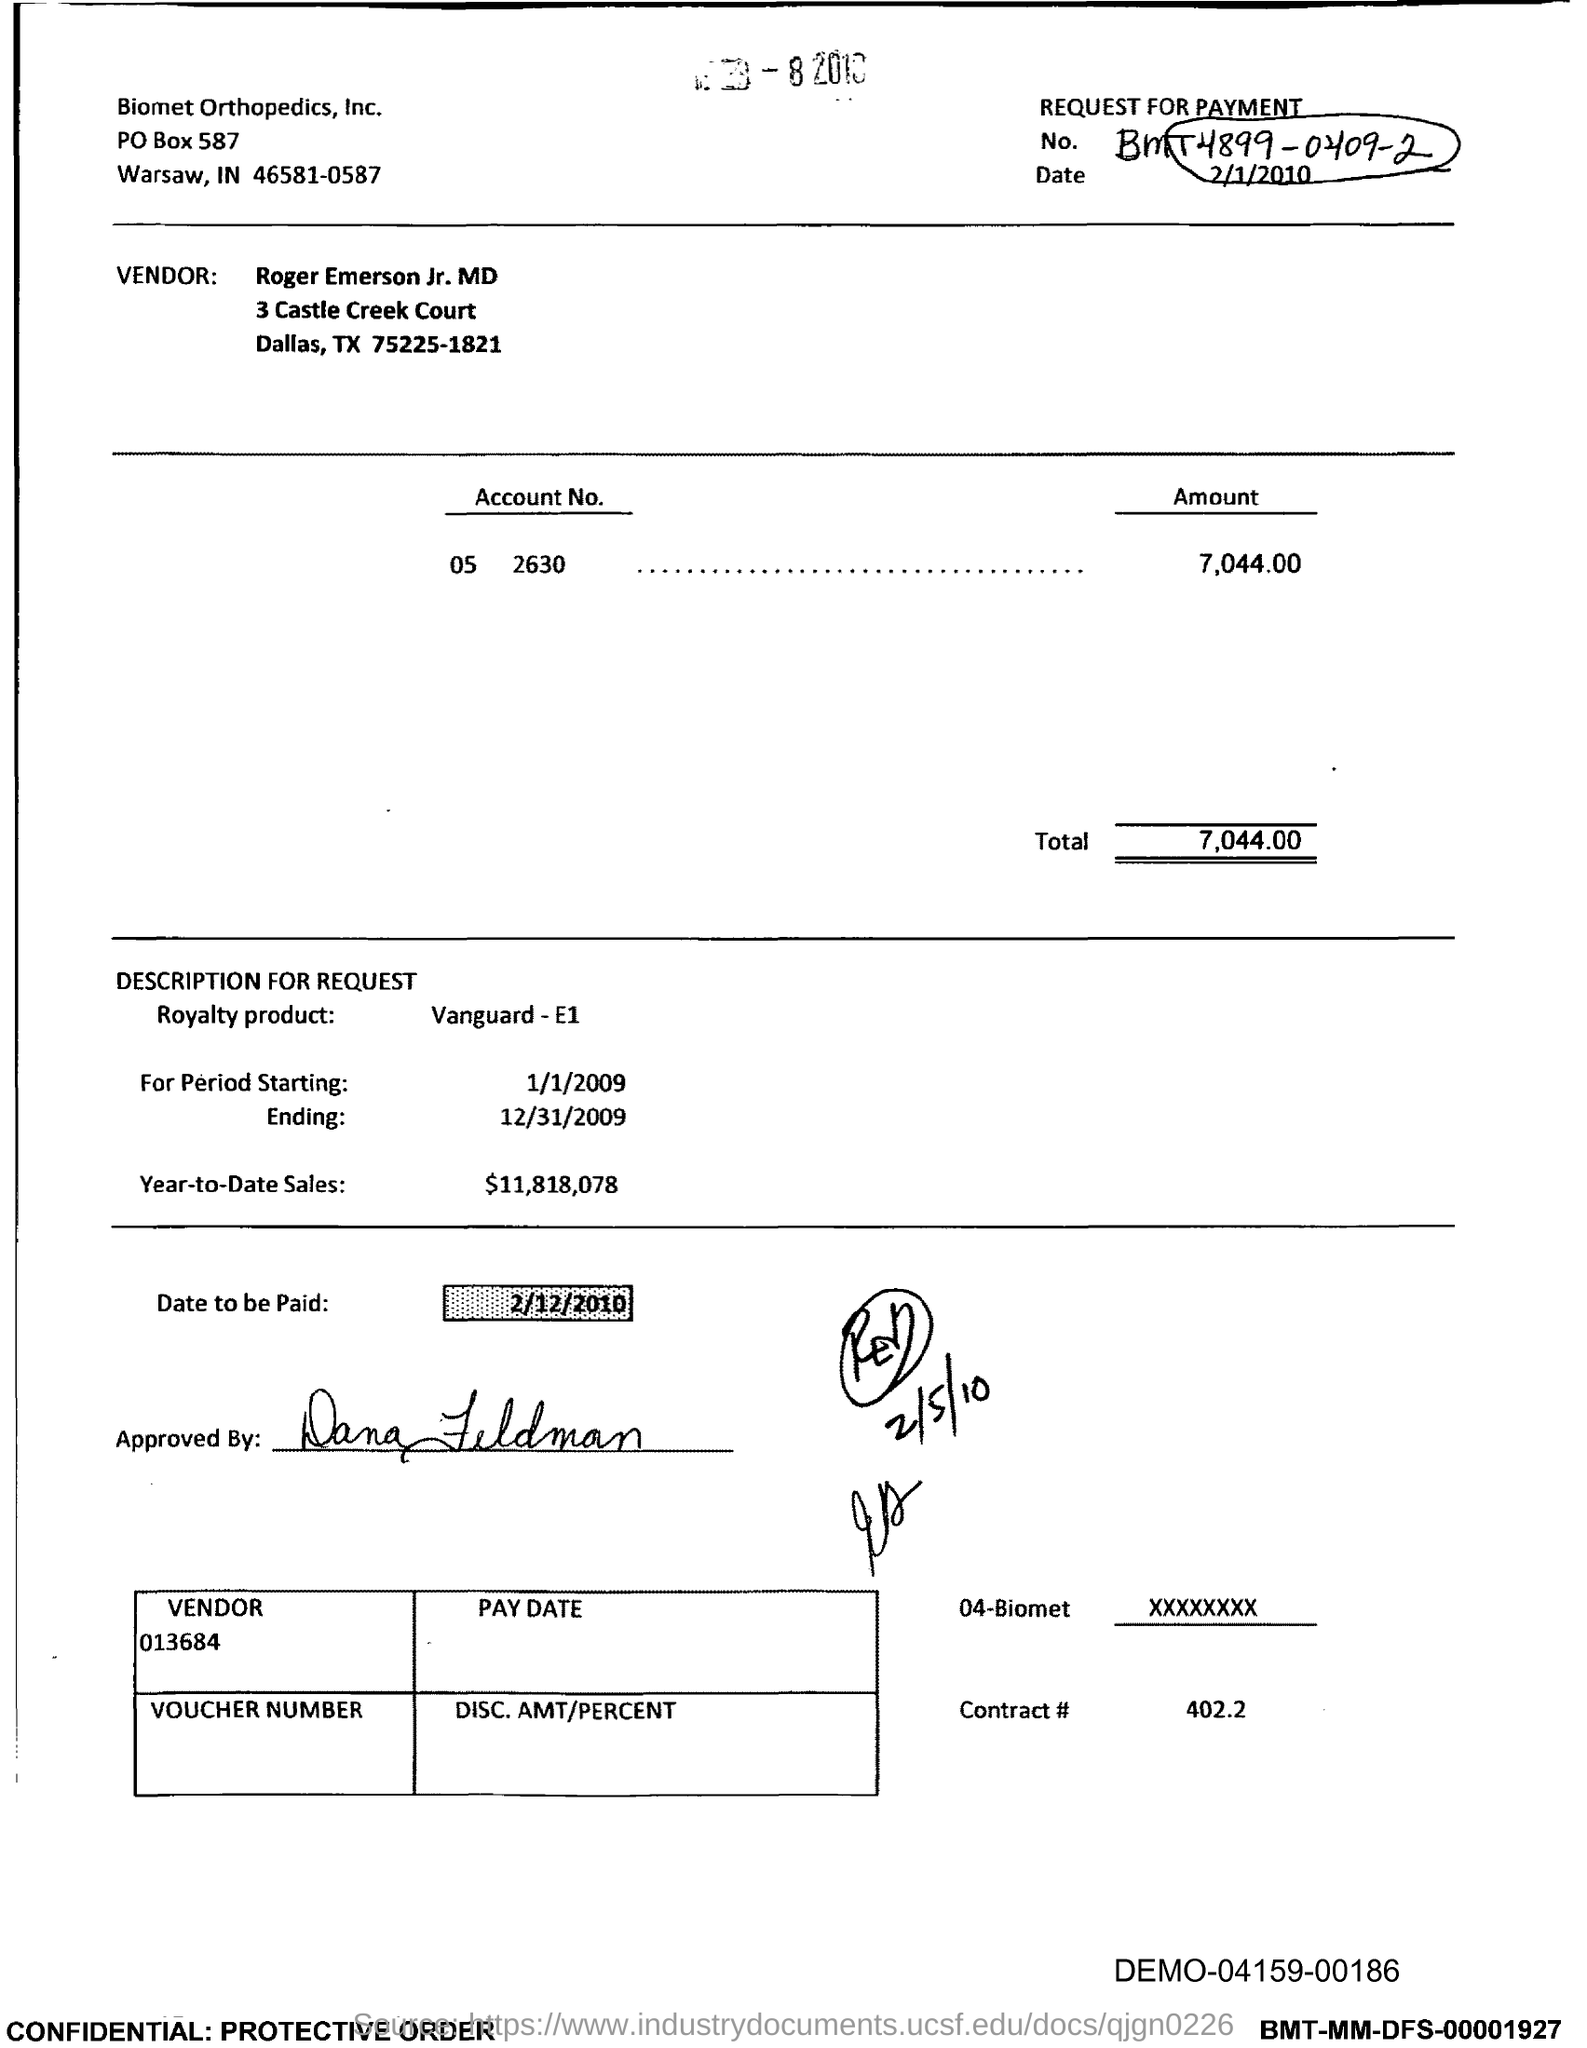In which state is biomet orthopedics, inc. located?
Offer a terse response. IN. What is the vendor no.?
Your answer should be very brief. 013684. What is the total?
Ensure brevity in your answer.  7,044.00. What is the name of royalty product ?
Give a very brief answer. Vanguard-E1. What is the year-to-date sales?
Your answer should be very brief. $11,818,078. What is the date to be paid ?
Your answer should be compact. 2/12/2010. What is the contract #?
Make the answer very short. 402.2. 